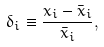<formula> <loc_0><loc_0><loc_500><loc_500>\delta _ { i } \equiv \frac { x _ { i } - \bar { x } _ { i } } { \bar { x } _ { i } } ,</formula> 